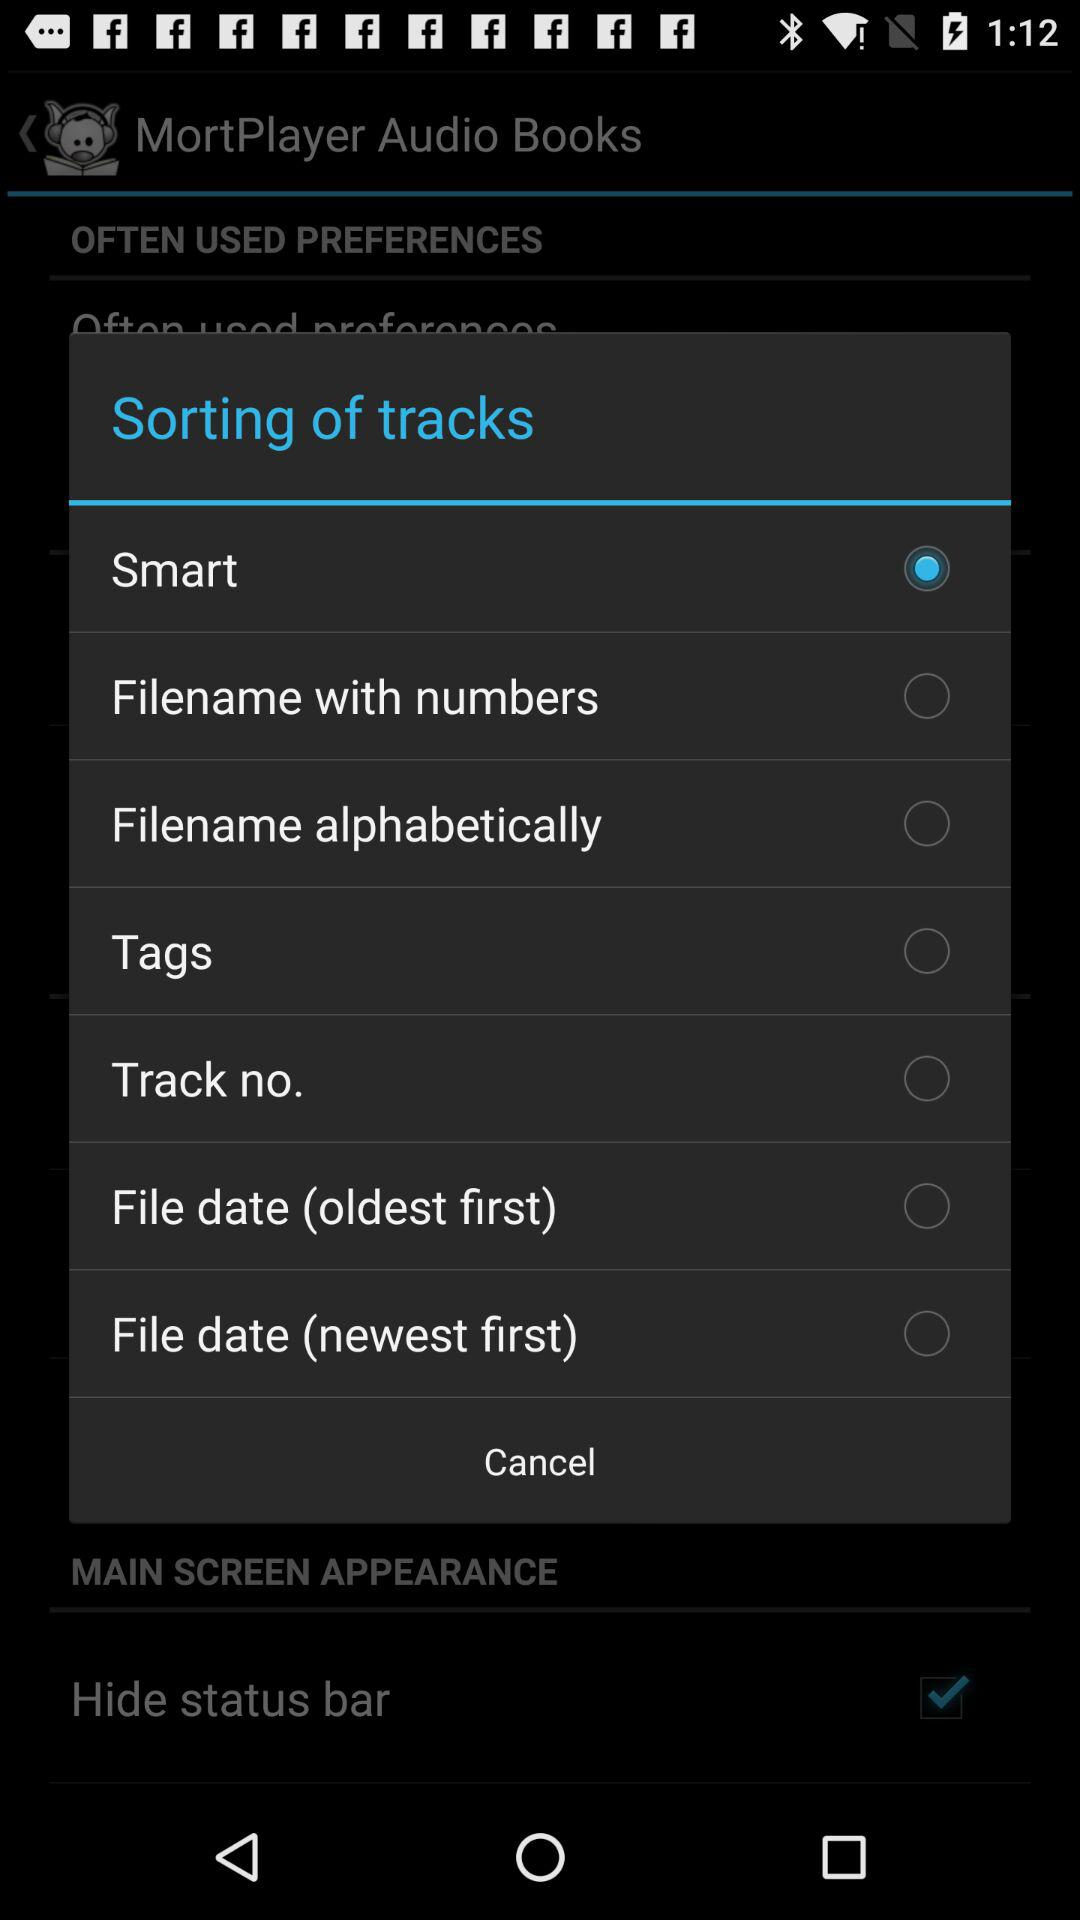Which preferences are used often?
When the provided information is insufficient, respond with <no answer>. <no answer> 